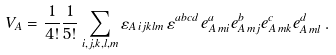Convert formula to latex. <formula><loc_0><loc_0><loc_500><loc_500>V _ { A } = \frac { 1 } { 4 ! } \frac { 1 } { 5 ! } \sum _ { i , j , k , l , m } \varepsilon _ { A \, i j k l m } \, \varepsilon ^ { a b c d } \, e ^ { a } _ { A \, m i } e ^ { b } _ { A \, m j } e ^ { c } _ { A \, m k } e ^ { d } _ { A \, m l } \, .</formula> 